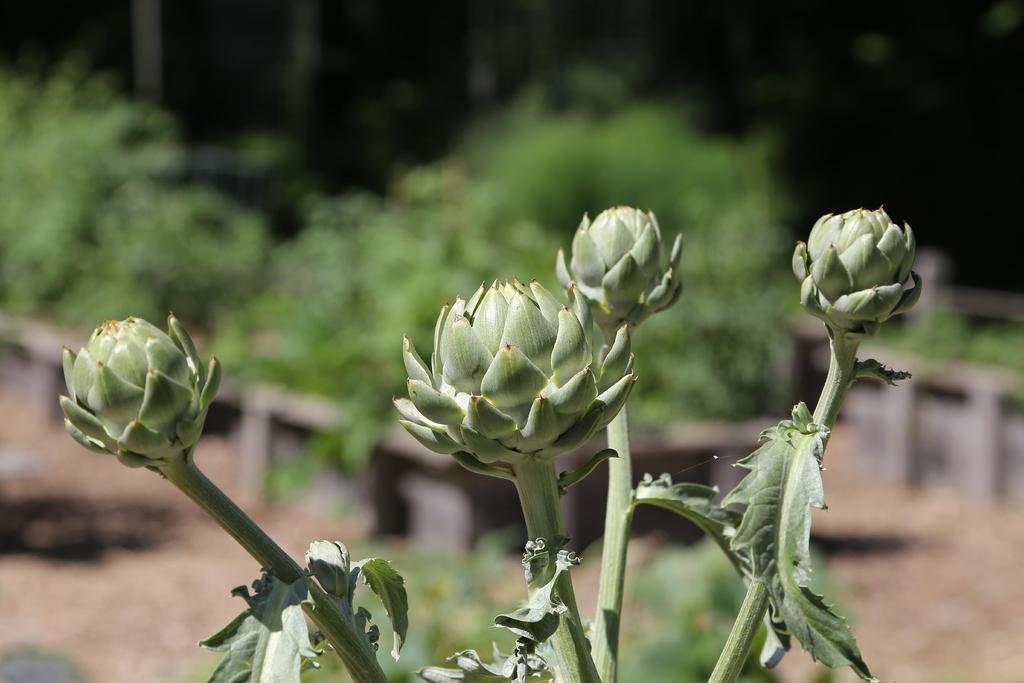How would you summarize this image in a sentence or two? In this picture I can see a plant with buds, and there is blur background. 